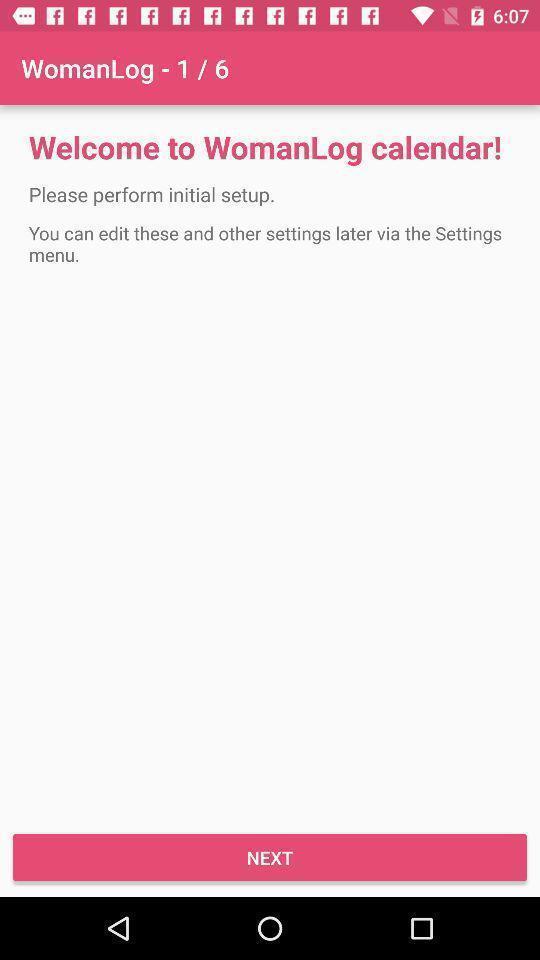Describe this image in words. Welcome page of the woman period tracking app. 